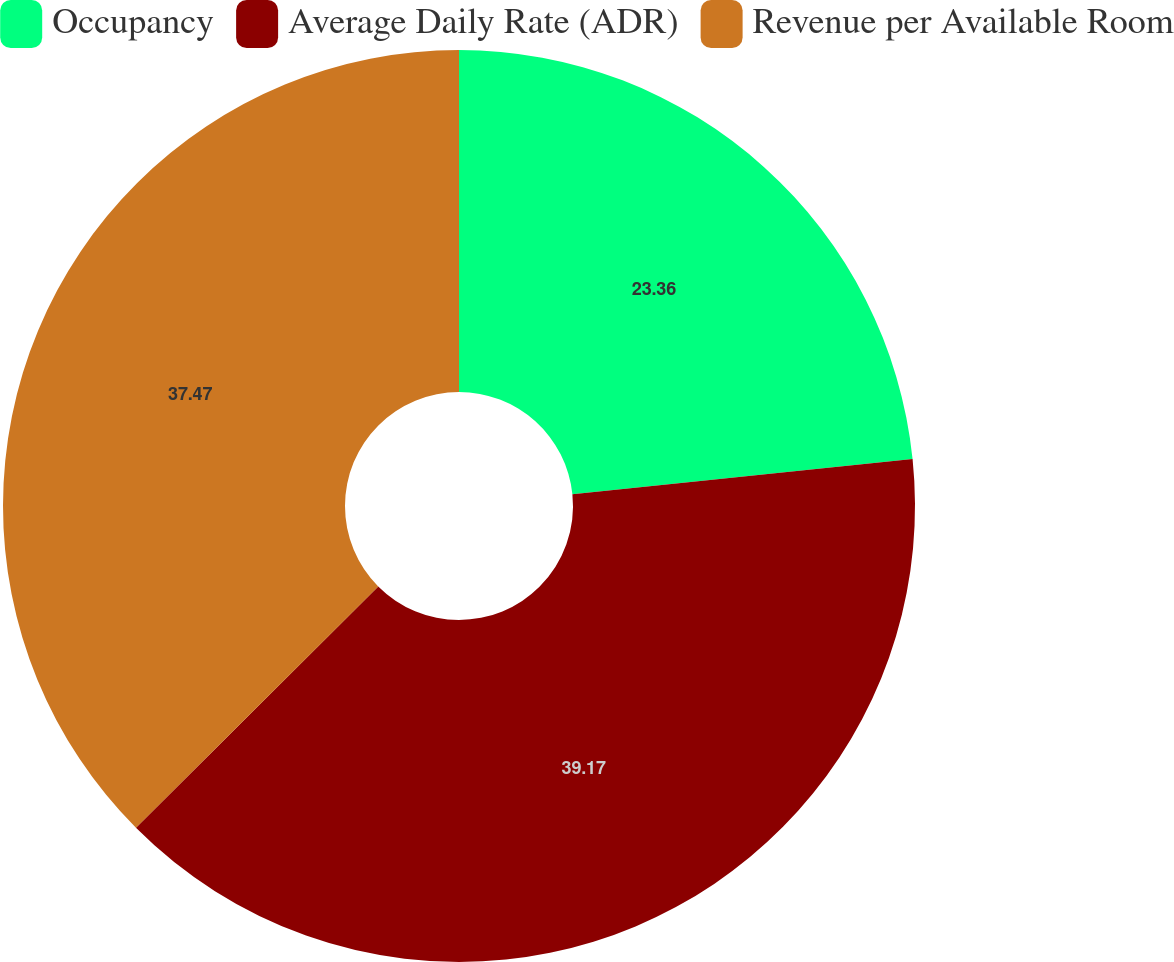Convert chart. <chart><loc_0><loc_0><loc_500><loc_500><pie_chart><fcel>Occupancy<fcel>Average Daily Rate (ADR)<fcel>Revenue per Available Room<nl><fcel>23.36%<fcel>39.17%<fcel>37.47%<nl></chart> 